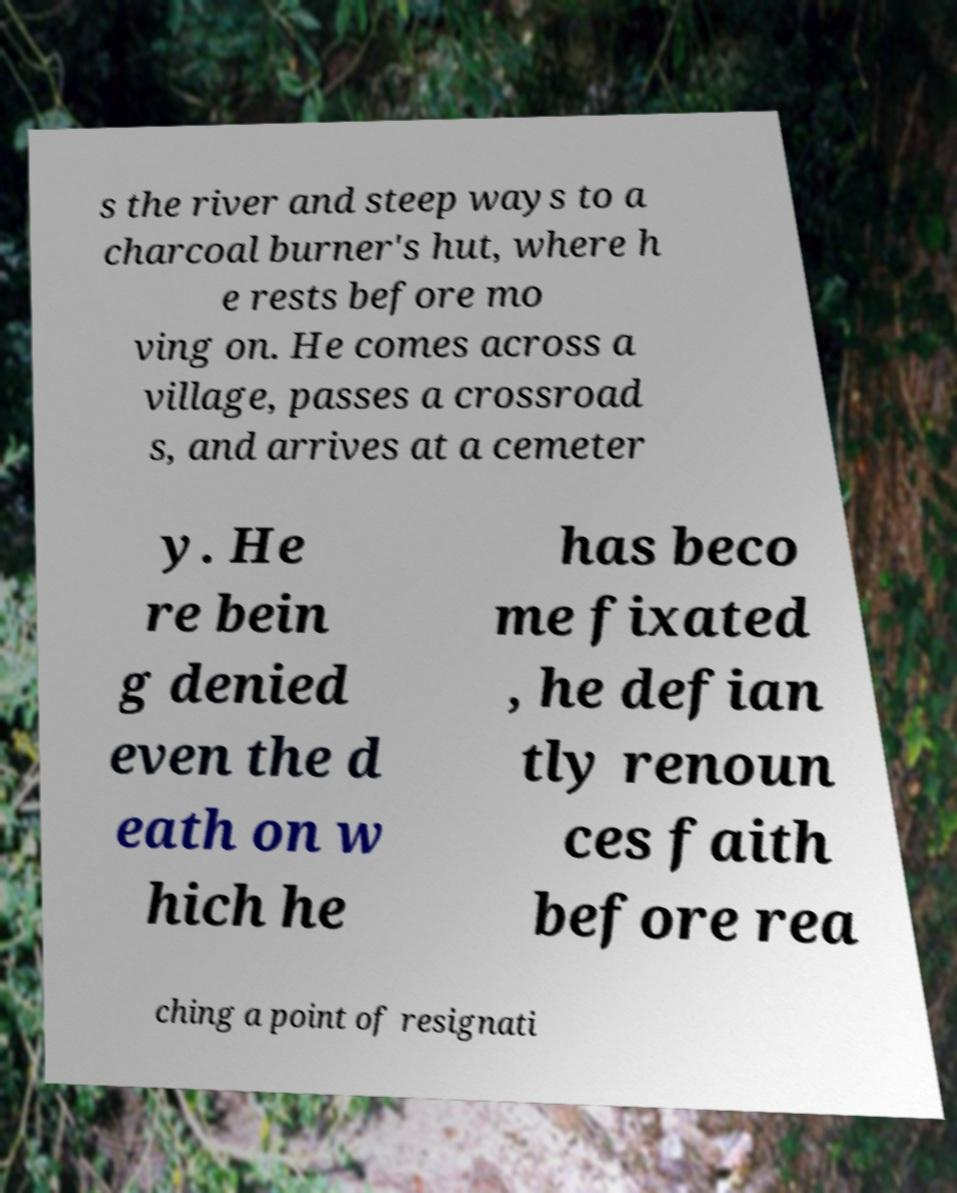Please identify and transcribe the text found in this image. s the river and steep ways to a charcoal burner's hut, where h e rests before mo ving on. He comes across a village, passes a crossroad s, and arrives at a cemeter y. He re bein g denied even the d eath on w hich he has beco me fixated , he defian tly renoun ces faith before rea ching a point of resignati 